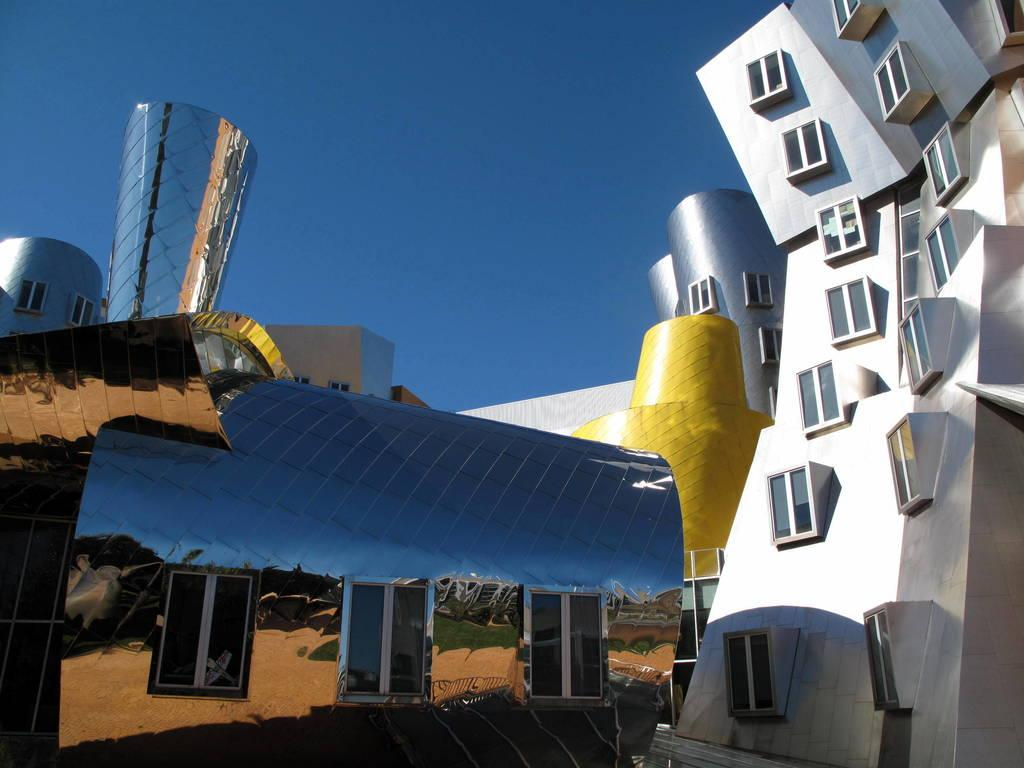What type of structures can be seen in the image? There are buildings in the image. What part of the natural environment is visible in the image? The sky is visible in the image. What type of behavior can be observed in the buildings in the image? The buildings in the image do not exhibit any behavior, as they are inanimate structures. What event is taking place in the image? There is no specific event taking place in the image; it simply shows buildings and the sky. 